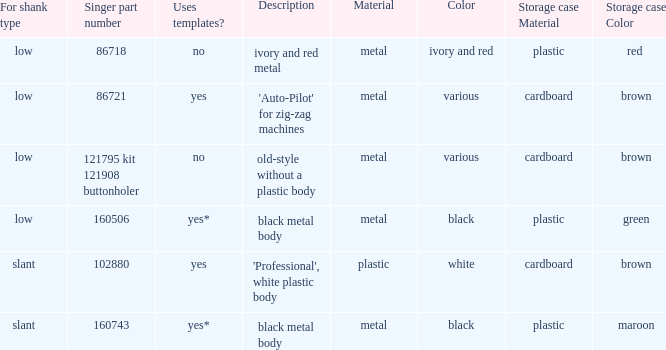What's the description of the buttonholer whose singer part number is 121795 kit 121908 buttonholer? Old-style without a plastic body. 